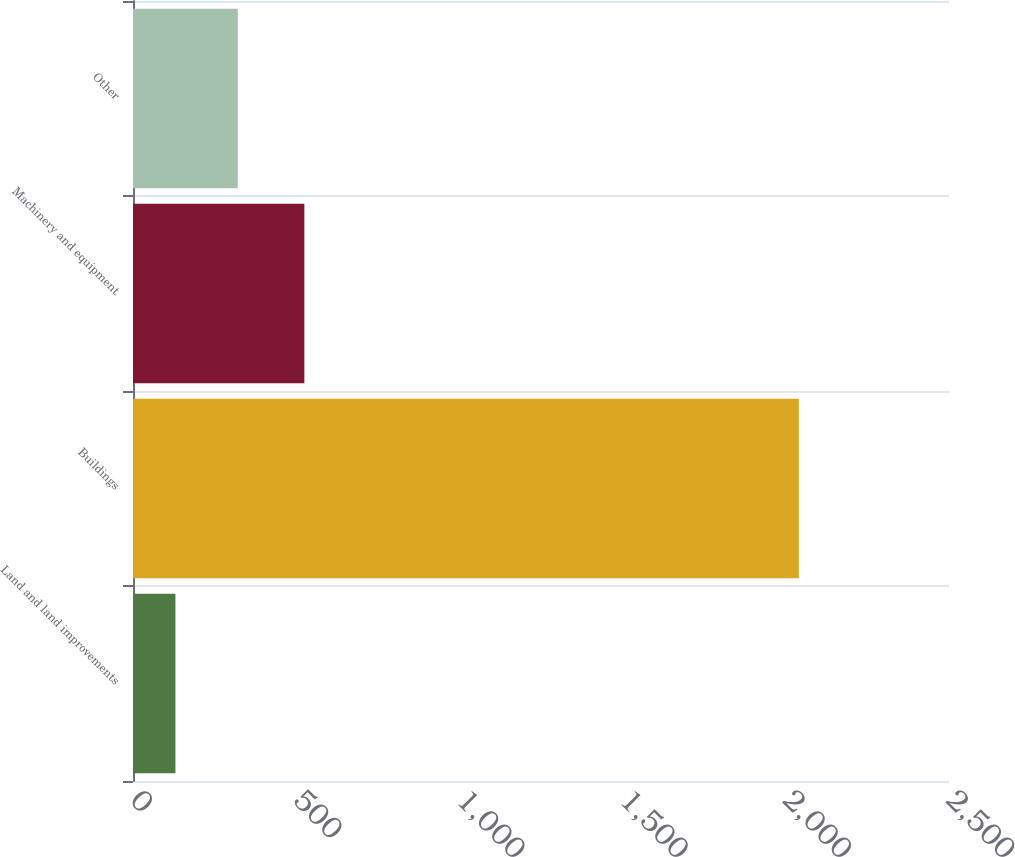<chart> <loc_0><loc_0><loc_500><loc_500><bar_chart><fcel>Land and land improvements<fcel>Buildings<fcel>Machinery and equipment<fcel>Other<nl><fcel>130<fcel>2040<fcel>525<fcel>321<nl></chart> 